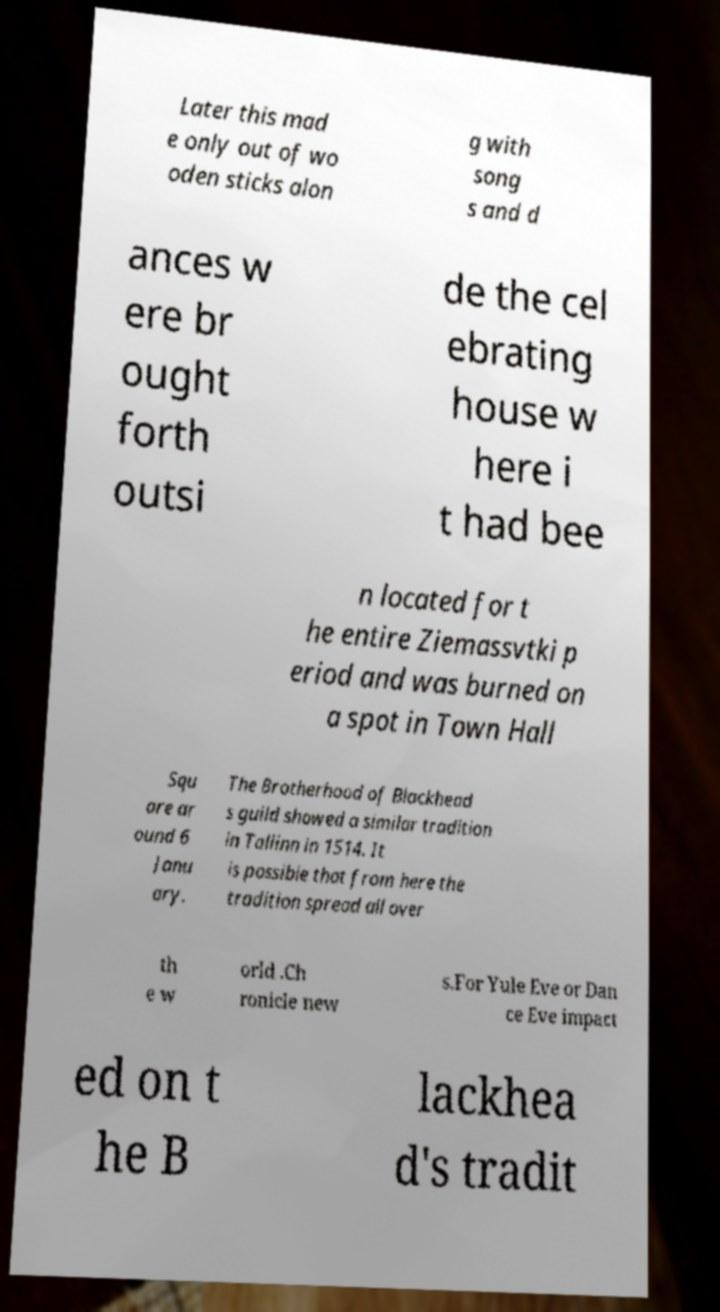What messages or text are displayed in this image? I need them in a readable, typed format. Later this mad e only out of wo oden sticks alon g with song s and d ances w ere br ought forth outsi de the cel ebrating house w here i t had bee n located for t he entire Ziemassvtki p eriod and was burned on a spot in Town Hall Squ are ar ound 6 Janu ary. The Brotherhood of Blackhead s guild showed a similar tradition in Tallinn in 1514. It is possible that from here the tradition spread all over th e w orld .Ch ronicle new s.For Yule Eve or Dan ce Eve impact ed on t he B lackhea d's tradit 